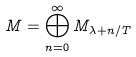Convert formula to latex. <formula><loc_0><loc_0><loc_500><loc_500>M = \bigoplus _ { n = 0 } ^ { \infty } M _ { \lambda + n / T }</formula> 